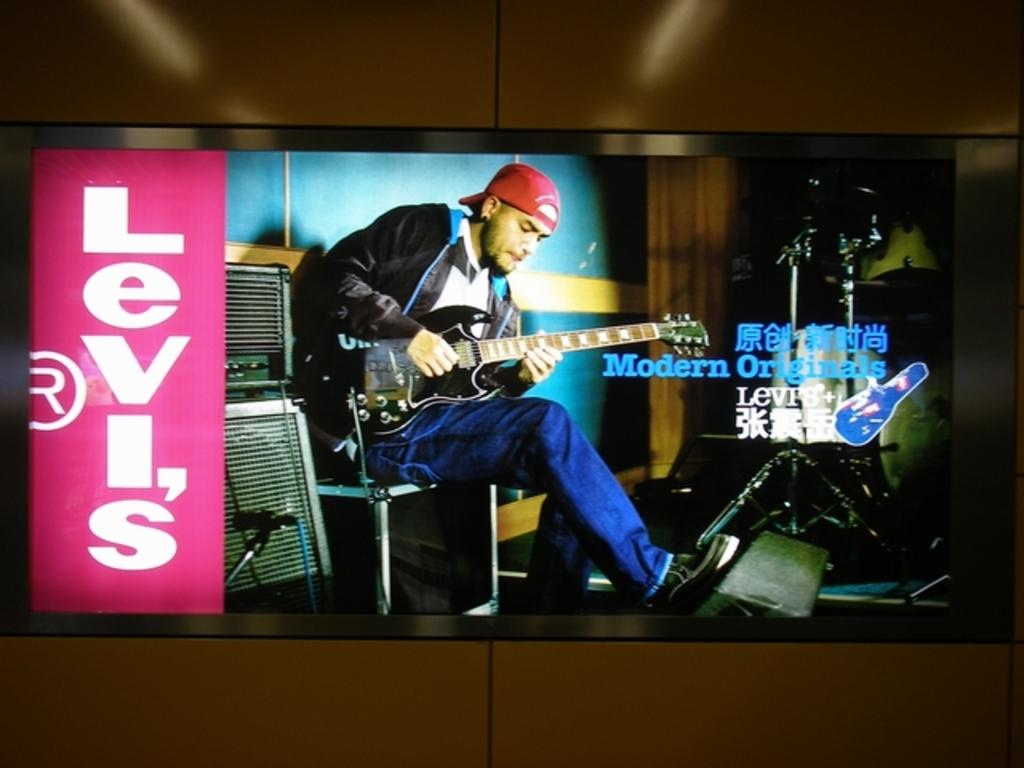<image>
Describe the image concisely. A screen with a man playing a guitar and the word Levi's on the left. 